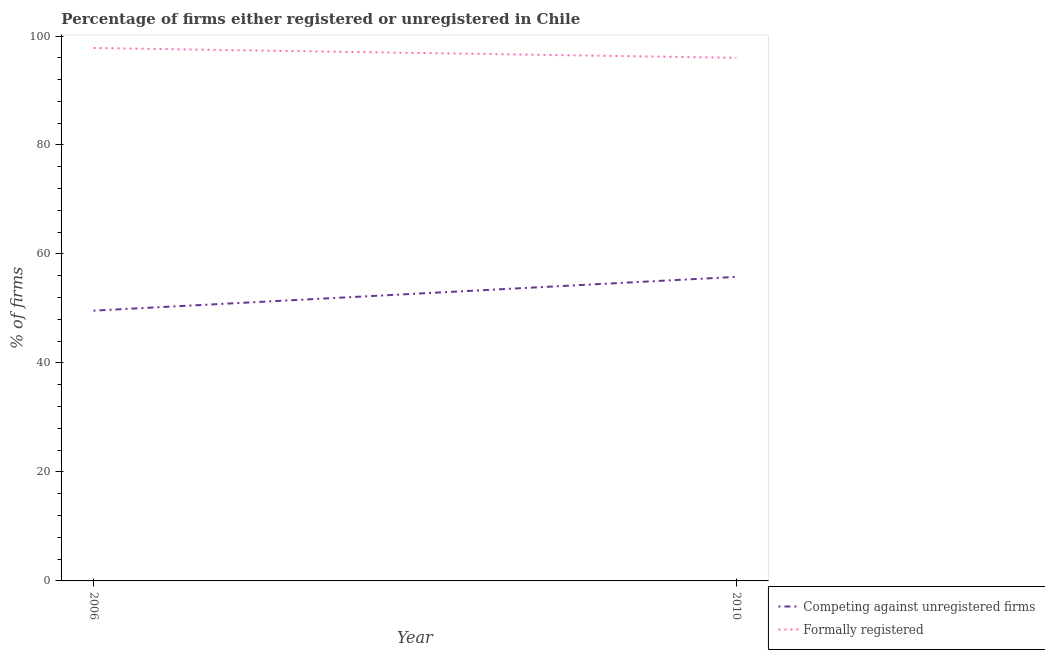How many different coloured lines are there?
Your response must be concise. 2. Does the line corresponding to percentage of registered firms intersect with the line corresponding to percentage of formally registered firms?
Provide a short and direct response. No. What is the percentage of formally registered firms in 2006?
Your answer should be very brief. 97.8. Across all years, what is the maximum percentage of formally registered firms?
Your answer should be compact. 97.8. Across all years, what is the minimum percentage of formally registered firms?
Provide a short and direct response. 96. In which year was the percentage of registered firms minimum?
Ensure brevity in your answer.  2006. What is the total percentage of registered firms in the graph?
Provide a short and direct response. 105.4. What is the difference between the percentage of registered firms in 2006 and that in 2010?
Your response must be concise. -6.2. What is the difference between the percentage of registered firms in 2006 and the percentage of formally registered firms in 2010?
Ensure brevity in your answer.  -46.4. What is the average percentage of formally registered firms per year?
Make the answer very short. 96.9. In the year 2010, what is the difference between the percentage of formally registered firms and percentage of registered firms?
Make the answer very short. 40.2. What is the ratio of the percentage of registered firms in 2006 to that in 2010?
Ensure brevity in your answer.  0.89. Does the percentage of registered firms monotonically increase over the years?
Make the answer very short. Yes. Is the percentage of registered firms strictly greater than the percentage of formally registered firms over the years?
Make the answer very short. No. Does the graph contain any zero values?
Provide a succinct answer. No. Does the graph contain grids?
Your answer should be compact. No. Where does the legend appear in the graph?
Your answer should be very brief. Bottom right. How many legend labels are there?
Your response must be concise. 2. What is the title of the graph?
Your answer should be very brief. Percentage of firms either registered or unregistered in Chile. Does "Official creditors" appear as one of the legend labels in the graph?
Your answer should be compact. No. What is the label or title of the X-axis?
Give a very brief answer. Year. What is the label or title of the Y-axis?
Your answer should be compact. % of firms. What is the % of firms in Competing against unregistered firms in 2006?
Your answer should be very brief. 49.6. What is the % of firms of Formally registered in 2006?
Your response must be concise. 97.8. What is the % of firms of Competing against unregistered firms in 2010?
Make the answer very short. 55.8. What is the % of firms of Formally registered in 2010?
Your answer should be very brief. 96. Across all years, what is the maximum % of firms of Competing against unregistered firms?
Make the answer very short. 55.8. Across all years, what is the maximum % of firms of Formally registered?
Ensure brevity in your answer.  97.8. Across all years, what is the minimum % of firms in Competing against unregistered firms?
Ensure brevity in your answer.  49.6. Across all years, what is the minimum % of firms in Formally registered?
Provide a succinct answer. 96. What is the total % of firms of Competing against unregistered firms in the graph?
Ensure brevity in your answer.  105.4. What is the total % of firms in Formally registered in the graph?
Your answer should be very brief. 193.8. What is the difference between the % of firms of Competing against unregistered firms in 2006 and the % of firms of Formally registered in 2010?
Make the answer very short. -46.4. What is the average % of firms in Competing against unregistered firms per year?
Give a very brief answer. 52.7. What is the average % of firms in Formally registered per year?
Keep it short and to the point. 96.9. In the year 2006, what is the difference between the % of firms in Competing against unregistered firms and % of firms in Formally registered?
Keep it short and to the point. -48.2. In the year 2010, what is the difference between the % of firms of Competing against unregistered firms and % of firms of Formally registered?
Ensure brevity in your answer.  -40.2. What is the ratio of the % of firms in Formally registered in 2006 to that in 2010?
Provide a short and direct response. 1.02. What is the difference between the highest and the second highest % of firms of Competing against unregistered firms?
Keep it short and to the point. 6.2. What is the difference between the highest and the lowest % of firms in Competing against unregistered firms?
Your answer should be compact. 6.2. What is the difference between the highest and the lowest % of firms of Formally registered?
Your response must be concise. 1.8. 